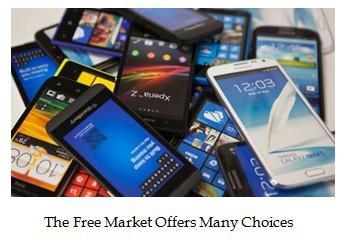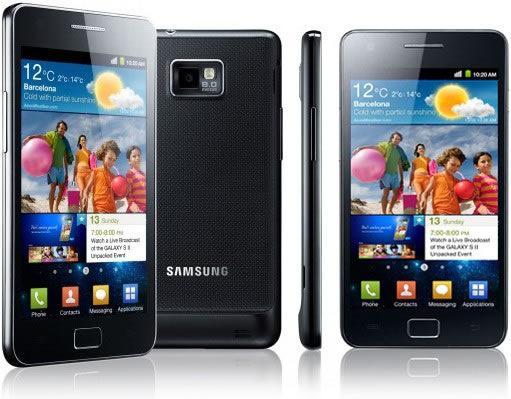The first image is the image on the left, the second image is the image on the right. Considering the images on both sides, is "In at least one image there are vertical phones." valid? Answer yes or no. Yes. The first image is the image on the left, the second image is the image on the right. Given the left and right images, does the statement "One image contains multiple devices with none overlapping, and the other image contains multiple devices with at least some overlapping." hold true? Answer yes or no. No. 